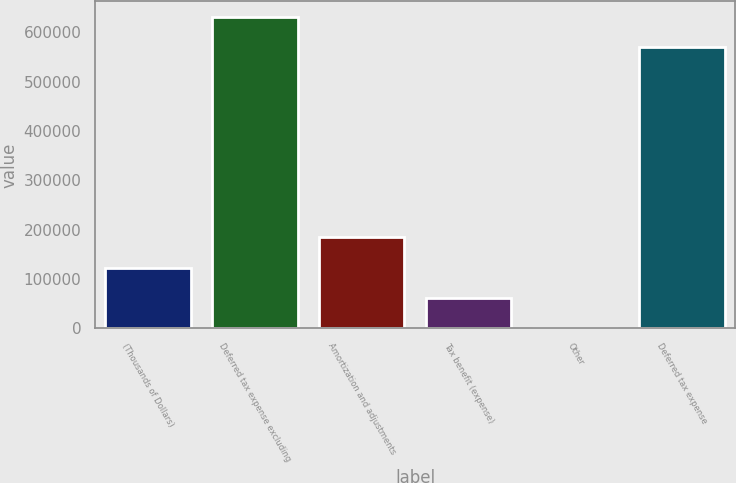Convert chart to OTSL. <chart><loc_0><loc_0><loc_500><loc_500><bar_chart><fcel>(Thousands of Dollars)<fcel>Deferred tax expense excluding<fcel>Amortization and adjustments<fcel>Tax benefit (expense)<fcel>Other<fcel>Deferred tax expense<nl><fcel>123388<fcel>631071<fcel>185081<fcel>61694.3<fcel>1<fcel>569378<nl></chart> 